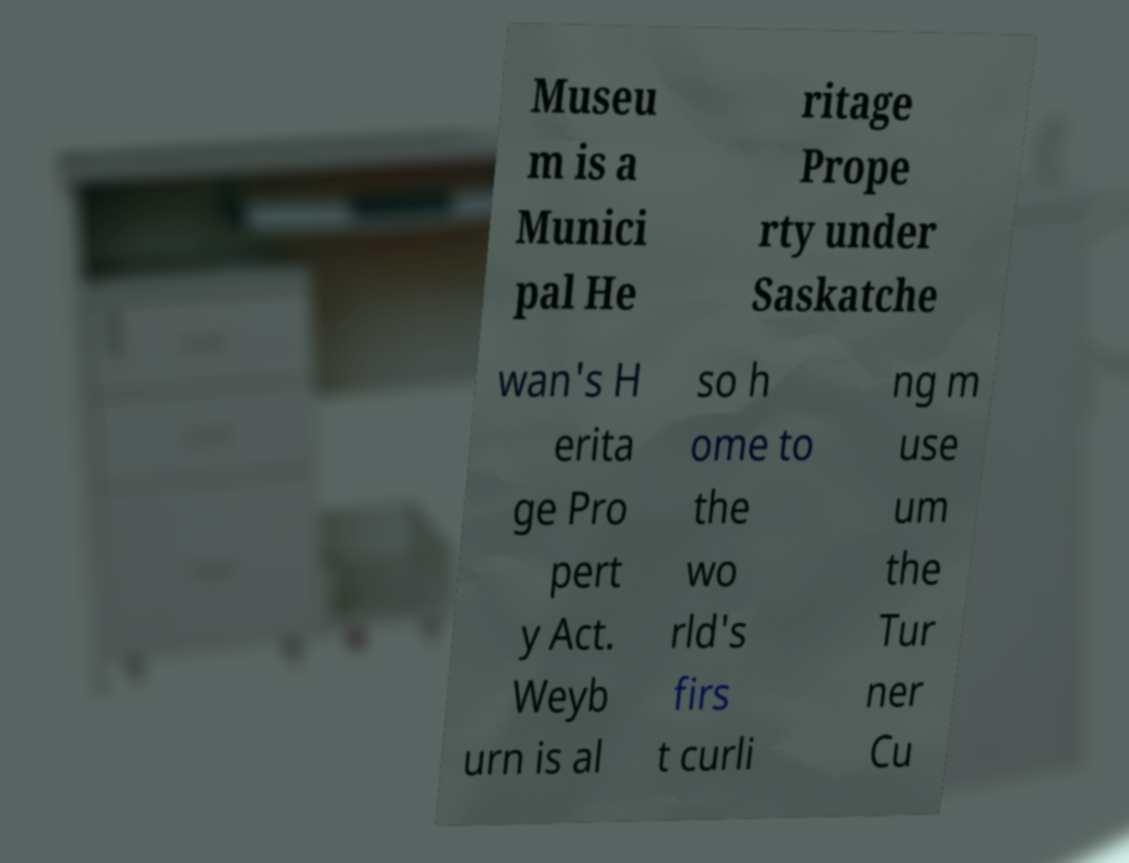Can you read and provide the text displayed in the image?This photo seems to have some interesting text. Can you extract and type it out for me? Museu m is a Munici pal He ritage Prope rty under Saskatche wan's H erita ge Pro pert y Act. Weyb urn is al so h ome to the wo rld's firs t curli ng m use um the Tur ner Cu 